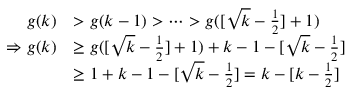Convert formula to latex. <formula><loc_0><loc_0><loc_500><loc_500>\begin{array} { r l } { g ( k ) } & { > g ( k - 1 ) > \cdots > g ( [ \sqrt { k } - \frac { 1 } { 2 } ] + 1 ) } \\ { \Rightarrow g ( k ) } & { \geq g ( [ \sqrt { k } - \frac { 1 } { 2 } ] + 1 ) + k - 1 - [ \sqrt { k } - \frac { 1 } { 2 } ] } \\ & { \geq 1 + k - 1 - [ \sqrt { k } - \frac { 1 } { 2 } ] = k - [ k - \frac { 1 } { 2 } ] } \end{array}</formula> 